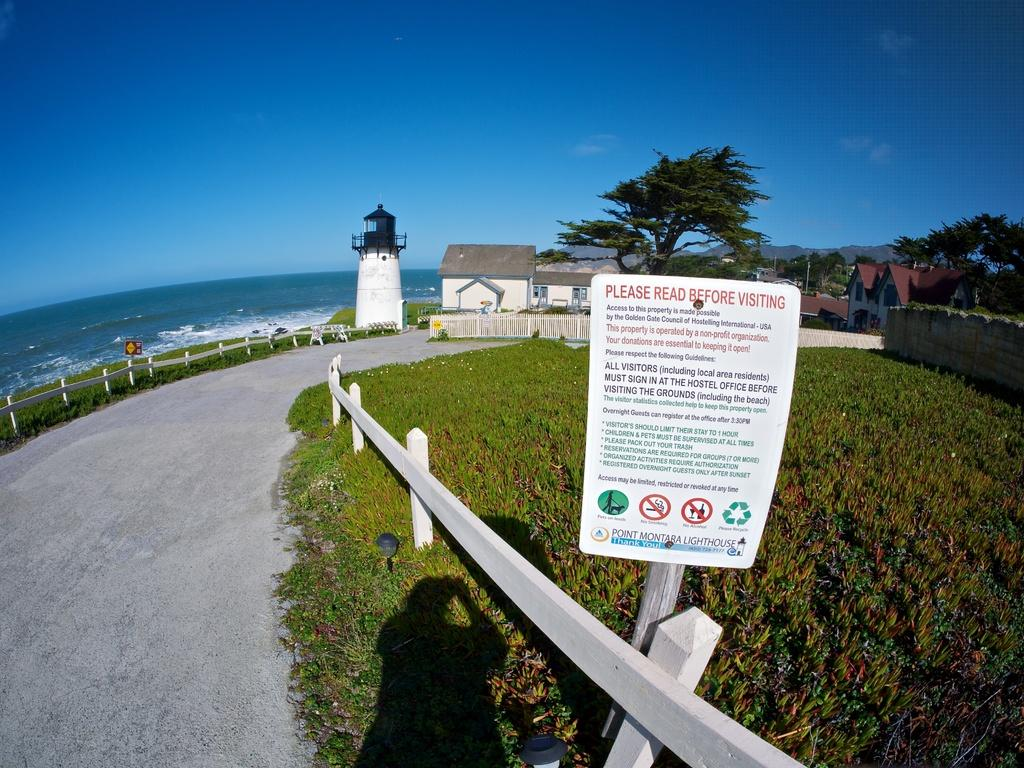What type of structures can be seen in the image? There are houses in the image. What natural elements are present in the image? There are trees in the image. What man-made objects can be seen in the image? There are poles, boards, a chimney, and fences in the image. What is visible at the bottom of the image? There is water and a road visible at the bottom of the image. What type of record can be seen on the chimney in the image? There is no record present on the chimney in the image. What title is given to the trees in the image? The trees in the image do not have a specific title. 